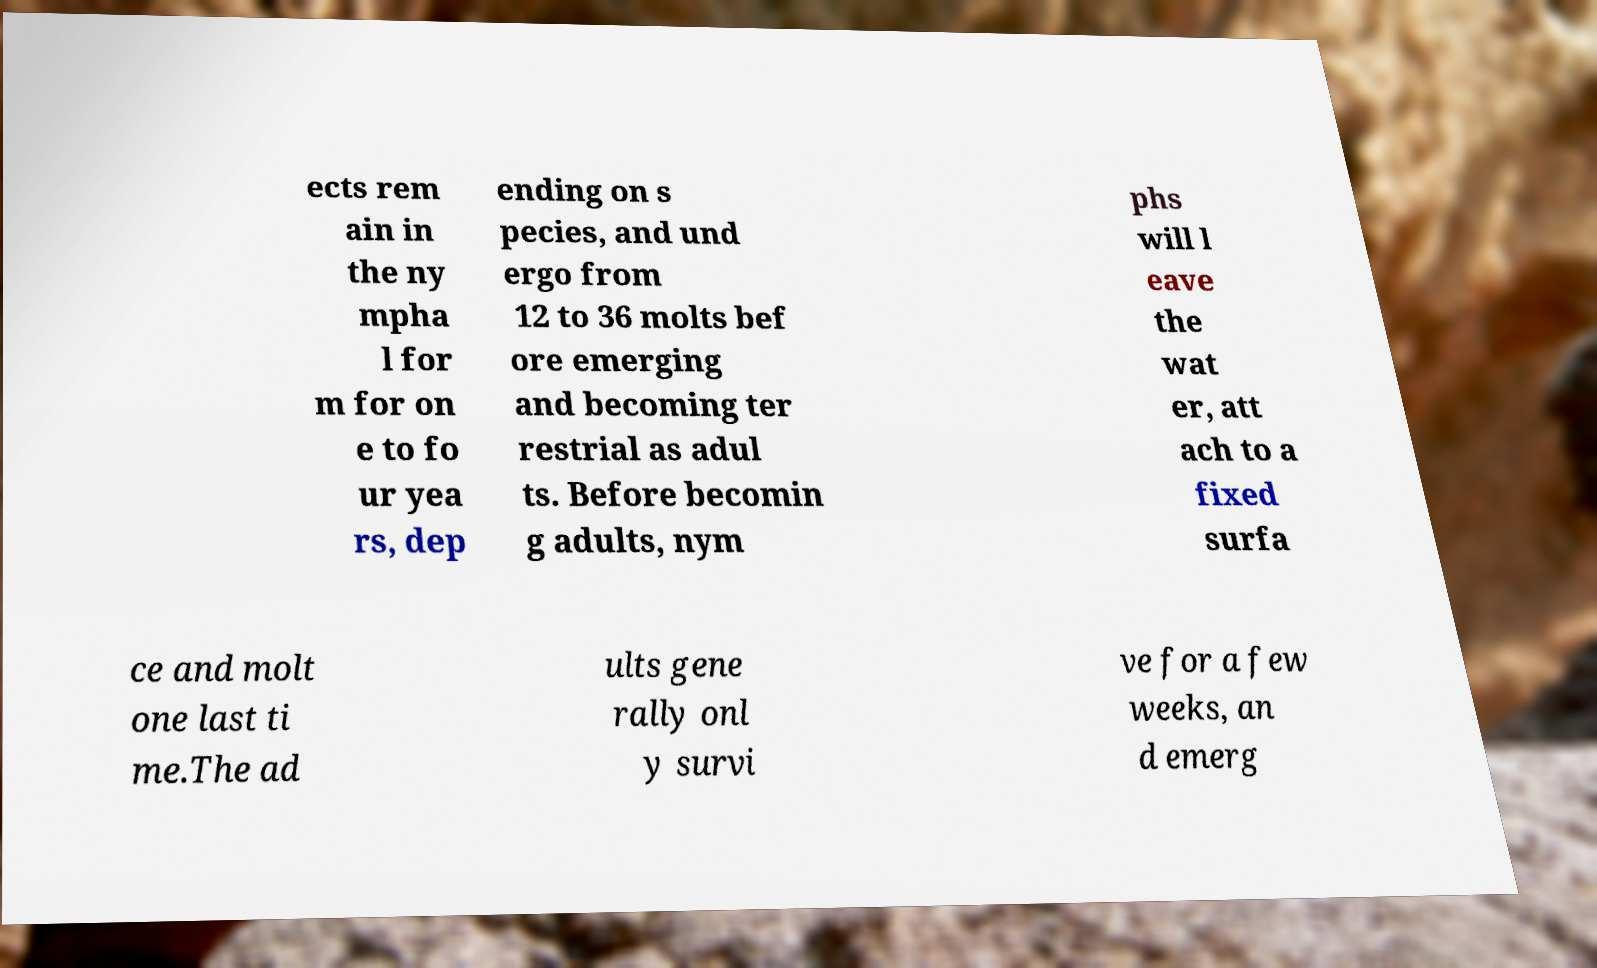Could you extract and type out the text from this image? ects rem ain in the ny mpha l for m for on e to fo ur yea rs, dep ending on s pecies, and und ergo from 12 to 36 molts bef ore emerging and becoming ter restrial as adul ts. Before becomin g adults, nym phs will l eave the wat er, att ach to a fixed surfa ce and molt one last ti me.The ad ults gene rally onl y survi ve for a few weeks, an d emerg 